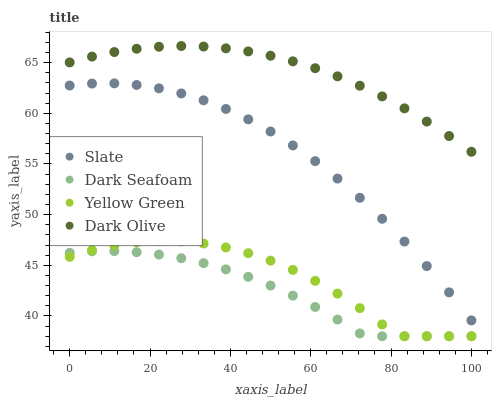Does Dark Seafoam have the minimum area under the curve?
Answer yes or no. Yes. Does Dark Olive have the maximum area under the curve?
Answer yes or no. Yes. Does Dark Olive have the minimum area under the curve?
Answer yes or no. No. Does Dark Seafoam have the maximum area under the curve?
Answer yes or no. No. Is Dark Olive the smoothest?
Answer yes or no. Yes. Is Yellow Green the roughest?
Answer yes or no. Yes. Is Dark Seafoam the smoothest?
Answer yes or no. No. Is Dark Seafoam the roughest?
Answer yes or no. No. Does Dark Seafoam have the lowest value?
Answer yes or no. Yes. Does Dark Olive have the lowest value?
Answer yes or no. No. Does Dark Olive have the highest value?
Answer yes or no. Yes. Does Dark Seafoam have the highest value?
Answer yes or no. No. Is Slate less than Dark Olive?
Answer yes or no. Yes. Is Dark Olive greater than Slate?
Answer yes or no. Yes. Does Dark Seafoam intersect Yellow Green?
Answer yes or no. Yes. Is Dark Seafoam less than Yellow Green?
Answer yes or no. No. Is Dark Seafoam greater than Yellow Green?
Answer yes or no. No. Does Slate intersect Dark Olive?
Answer yes or no. No. 